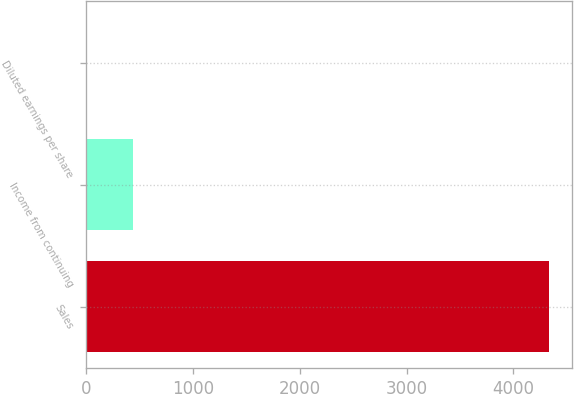Convert chart to OTSL. <chart><loc_0><loc_0><loc_500><loc_500><bar_chart><fcel>Sales<fcel>Income from continuing<fcel>Diluted earnings per share<nl><fcel>4332.5<fcel>434.63<fcel>1.53<nl></chart> 